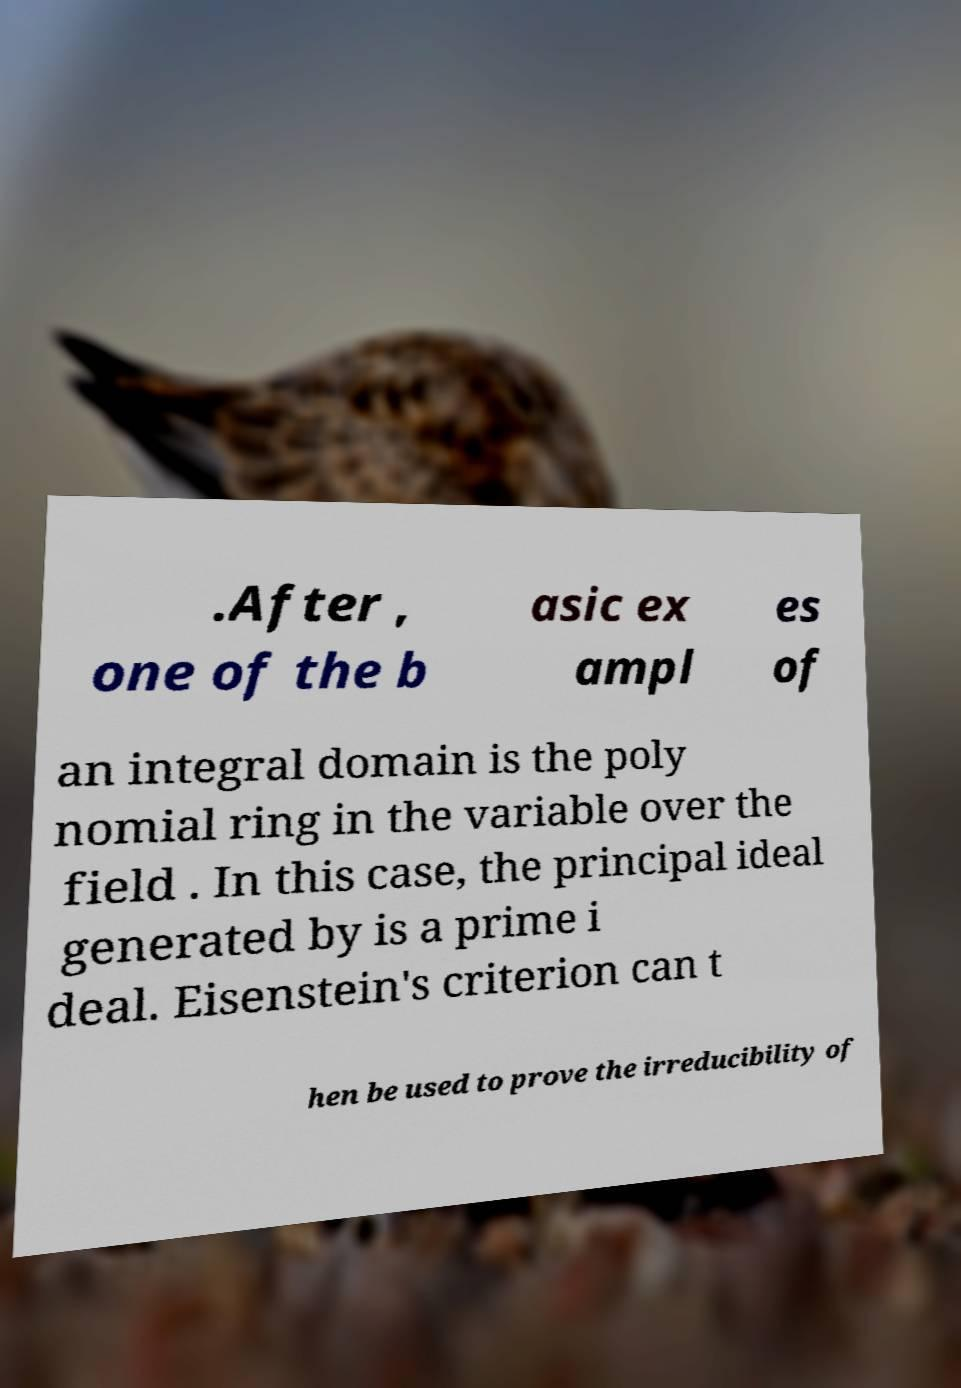I need the written content from this picture converted into text. Can you do that? .After , one of the b asic ex ampl es of an integral domain is the poly nomial ring in the variable over the field . In this case, the principal ideal generated by is a prime i deal. Eisenstein's criterion can t hen be used to prove the irreducibility of 